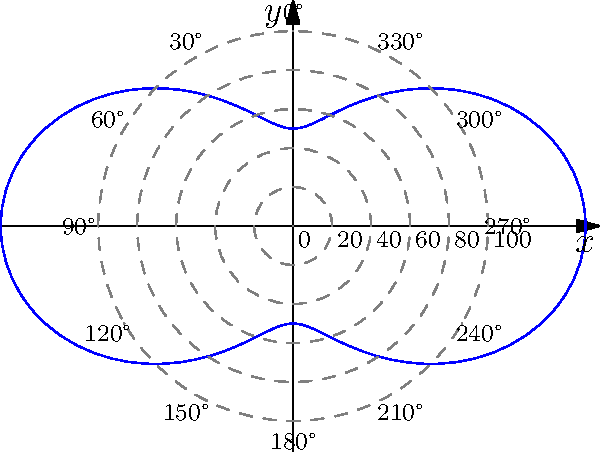In a radiotherapy treatment plan, the radiation dose distribution is modeled using the polar function $r(\theta) = 100(1 + 0.5\cos(2\theta))$, where $r$ represents the dose in cGy and $\theta$ is the angle in radians. Based on the polar graph shown, at which angle(s) does the radiation dose reach its maximum value? To find the maximum radiation dose, we need to analyze the given function and its graph:

1) The function is $r(\theta) = 100(1 + 0.5\cos(2\theta))$

2) The cosine function reaches its maximum value of 1 when its argument is a multiple of $2\pi$. In this case, we need $2\theta$ to be a multiple of $2\pi$.

3) Solving for $\theta$:
   $2\theta = 2\pi n$, where $n$ is an integer
   $\theta = \pi n$

4) Within the range $[0, 2\pi]$, this occurs when $\theta = 0$, $\pi$, and $2\pi$.

5) Converting to degrees:
   $0$ radians = $0°$
   $\pi$ radians = $180°$
   $2\pi$ radians = $360°$ (which is equivalent to $0°$)

6) Looking at the polar graph, we can confirm that the curve extends furthest from the origin (indicating maximum dose) at $0°$ and $180°$.

Therefore, the radiation dose reaches its maximum value at $0°$ (or $360°$) and $180°$.
Answer: $0°$ and $180°$ 